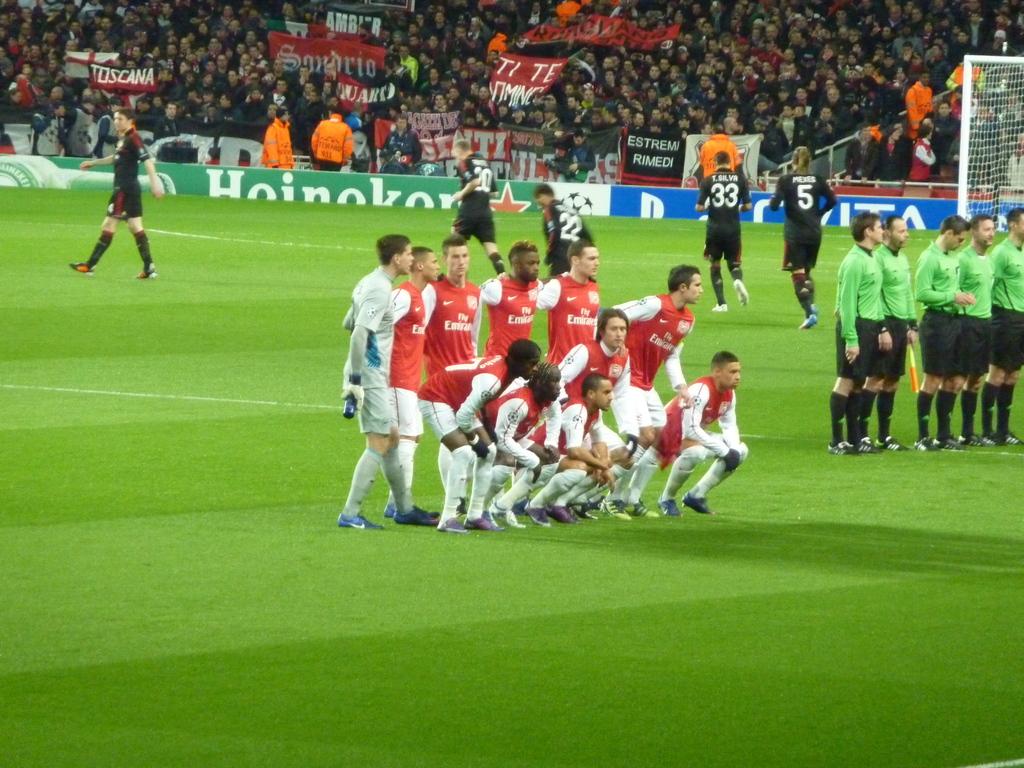What team is playing?
Offer a terse response. Fly emirates. What company sponsors the field?
Provide a short and direct response. Heineken. 